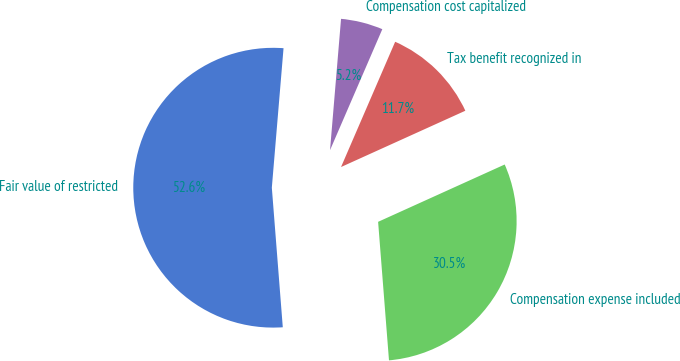Convert chart to OTSL. <chart><loc_0><loc_0><loc_500><loc_500><pie_chart><fcel>Fair value of restricted<fcel>Compensation expense included<fcel>Tax benefit recognized in<fcel>Compensation cost capitalized<nl><fcel>52.58%<fcel>30.52%<fcel>11.74%<fcel>5.16%<nl></chart> 